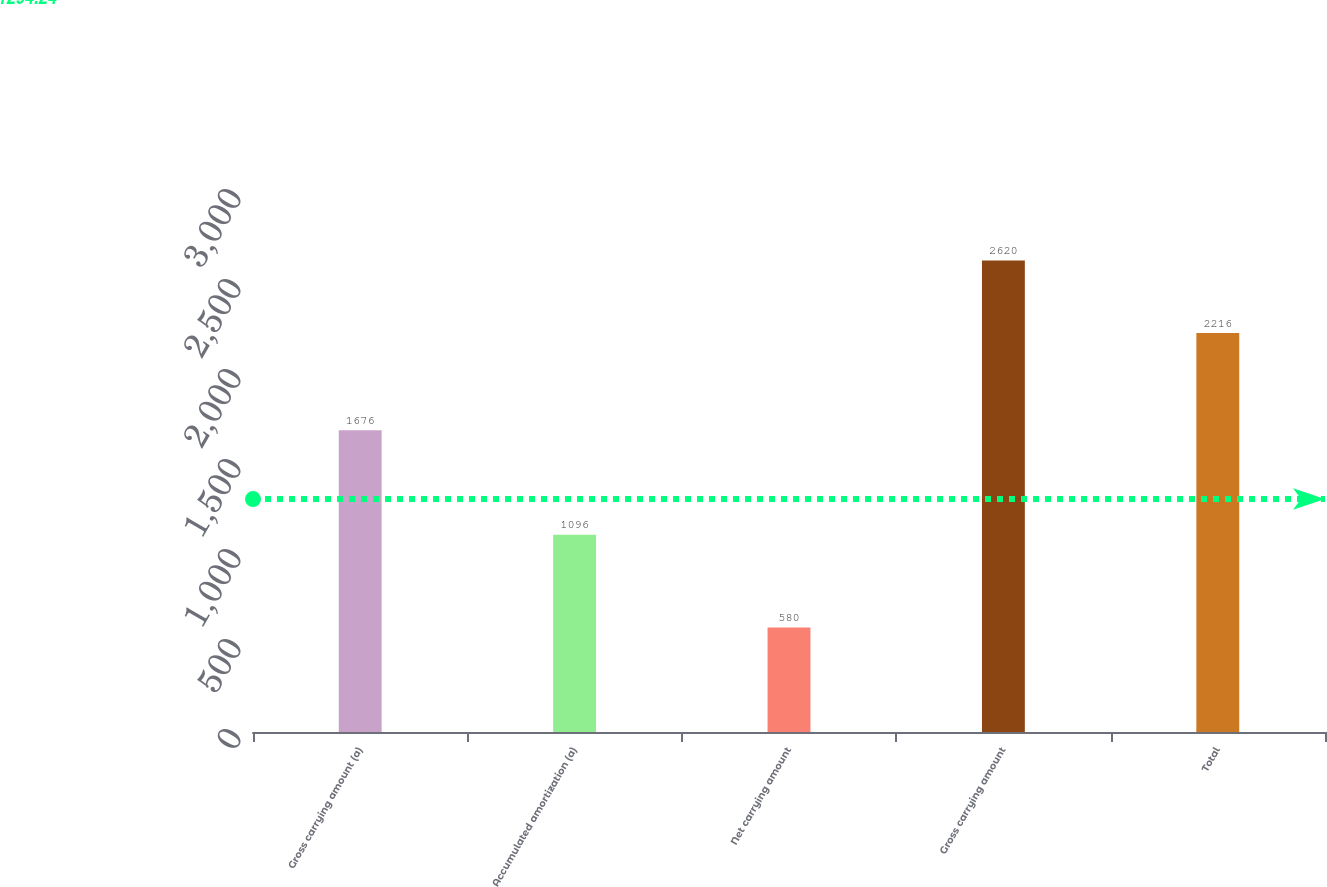Convert chart. <chart><loc_0><loc_0><loc_500><loc_500><bar_chart><fcel>Gross carrying amount (a)<fcel>Accumulated amortization (a)<fcel>Net carrying amount<fcel>Gross carrying amount<fcel>Total<nl><fcel>1676<fcel>1096<fcel>580<fcel>2620<fcel>2216<nl></chart> 